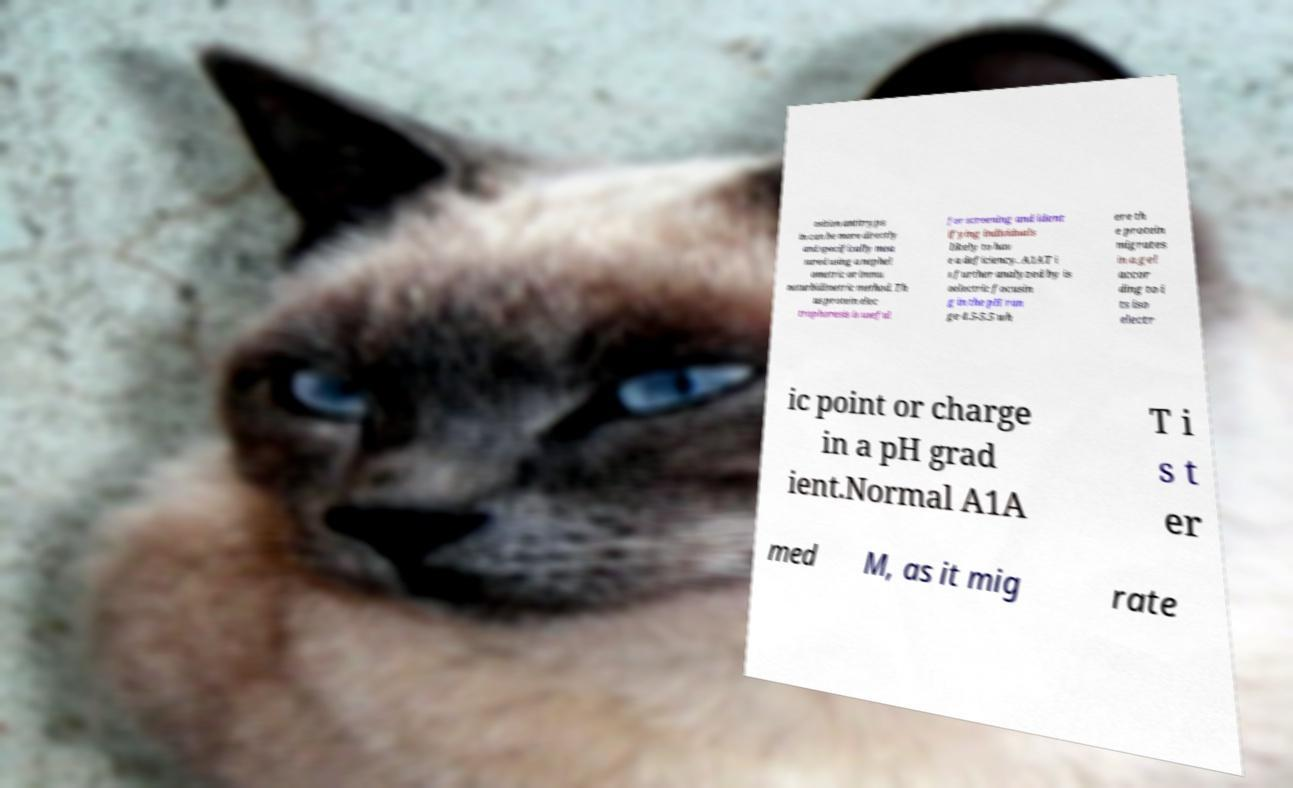What messages or text are displayed in this image? I need them in a readable, typed format. osition antitryps in can be more directly and specifically mea sured using a nephel ometric or immu noturbidimetric method. Th us protein elec trophoresis is useful for screening and ident ifying individuals likely to hav e a deficiency. A1AT i s further analyzed by is oelectric focusin g in the pH ran ge 4.5-5.5 wh ere th e protein migrates in a gel accor ding to i ts iso electr ic point or charge in a pH grad ient.Normal A1A T i s t er med M, as it mig rate 